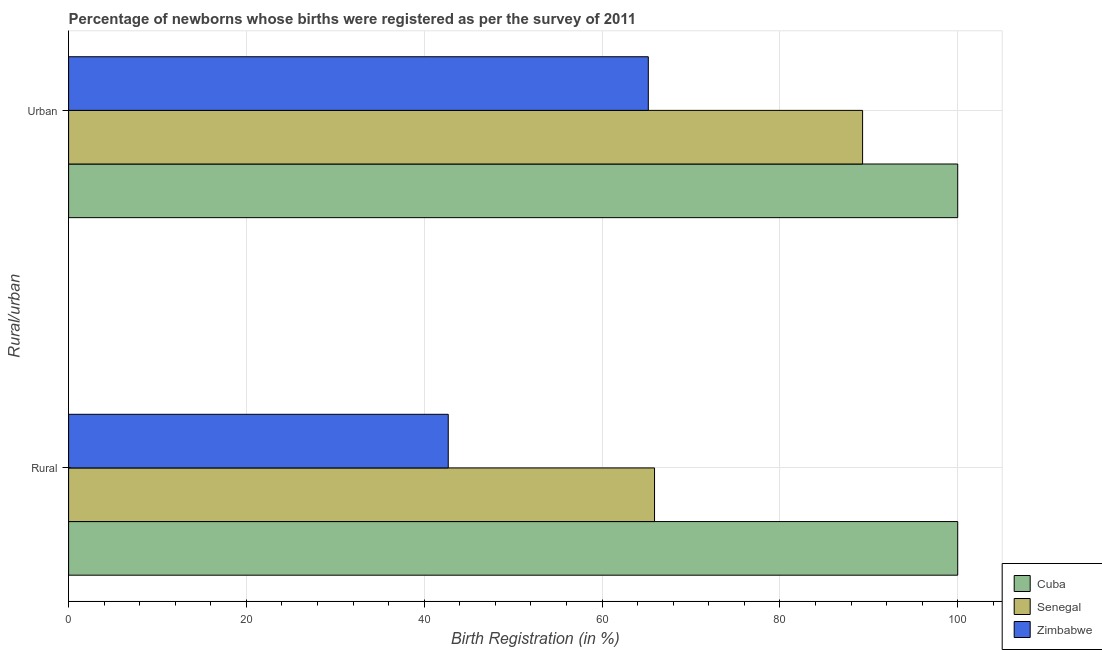How many different coloured bars are there?
Keep it short and to the point. 3. How many groups of bars are there?
Offer a very short reply. 2. Are the number of bars on each tick of the Y-axis equal?
Provide a short and direct response. Yes. What is the label of the 2nd group of bars from the top?
Provide a succinct answer. Rural. Across all countries, what is the minimum urban birth registration?
Keep it short and to the point. 65.2. In which country was the urban birth registration maximum?
Keep it short and to the point. Cuba. In which country was the urban birth registration minimum?
Your response must be concise. Zimbabwe. What is the total rural birth registration in the graph?
Provide a succinct answer. 208.6. What is the difference between the rural birth registration in Senegal and that in Cuba?
Provide a succinct answer. -34.1. What is the difference between the urban birth registration in Zimbabwe and the rural birth registration in Cuba?
Provide a short and direct response. -34.8. What is the average urban birth registration per country?
Give a very brief answer. 84.83. What is the difference between the urban birth registration and rural birth registration in Senegal?
Offer a very short reply. 23.4. In how many countries, is the urban birth registration greater than 12 %?
Give a very brief answer. 3. What is the ratio of the urban birth registration in Zimbabwe to that in Cuba?
Your answer should be very brief. 0.65. In how many countries, is the urban birth registration greater than the average urban birth registration taken over all countries?
Keep it short and to the point. 2. What does the 1st bar from the top in Urban represents?
Keep it short and to the point. Zimbabwe. What does the 1st bar from the bottom in Rural represents?
Provide a succinct answer. Cuba. Are all the bars in the graph horizontal?
Provide a succinct answer. Yes. How many countries are there in the graph?
Your response must be concise. 3. What is the difference between two consecutive major ticks on the X-axis?
Provide a short and direct response. 20. Are the values on the major ticks of X-axis written in scientific E-notation?
Provide a short and direct response. No. Does the graph contain any zero values?
Provide a short and direct response. No. Does the graph contain grids?
Offer a terse response. Yes. Where does the legend appear in the graph?
Offer a terse response. Bottom right. How many legend labels are there?
Offer a very short reply. 3. How are the legend labels stacked?
Your answer should be very brief. Vertical. What is the title of the graph?
Provide a short and direct response. Percentage of newborns whose births were registered as per the survey of 2011. What is the label or title of the X-axis?
Make the answer very short. Birth Registration (in %). What is the label or title of the Y-axis?
Your answer should be very brief. Rural/urban. What is the Birth Registration (in %) in Cuba in Rural?
Your answer should be compact. 100. What is the Birth Registration (in %) in Senegal in Rural?
Your answer should be compact. 65.9. What is the Birth Registration (in %) of Zimbabwe in Rural?
Your answer should be very brief. 42.7. What is the Birth Registration (in %) of Cuba in Urban?
Give a very brief answer. 100. What is the Birth Registration (in %) of Senegal in Urban?
Ensure brevity in your answer.  89.3. What is the Birth Registration (in %) in Zimbabwe in Urban?
Keep it short and to the point. 65.2. Across all Rural/urban, what is the maximum Birth Registration (in %) of Cuba?
Your answer should be very brief. 100. Across all Rural/urban, what is the maximum Birth Registration (in %) in Senegal?
Give a very brief answer. 89.3. Across all Rural/urban, what is the maximum Birth Registration (in %) in Zimbabwe?
Offer a very short reply. 65.2. Across all Rural/urban, what is the minimum Birth Registration (in %) in Senegal?
Your response must be concise. 65.9. Across all Rural/urban, what is the minimum Birth Registration (in %) of Zimbabwe?
Your answer should be very brief. 42.7. What is the total Birth Registration (in %) in Cuba in the graph?
Offer a very short reply. 200. What is the total Birth Registration (in %) in Senegal in the graph?
Offer a very short reply. 155.2. What is the total Birth Registration (in %) in Zimbabwe in the graph?
Keep it short and to the point. 107.9. What is the difference between the Birth Registration (in %) in Senegal in Rural and that in Urban?
Ensure brevity in your answer.  -23.4. What is the difference between the Birth Registration (in %) of Zimbabwe in Rural and that in Urban?
Provide a short and direct response. -22.5. What is the difference between the Birth Registration (in %) of Cuba in Rural and the Birth Registration (in %) of Senegal in Urban?
Your answer should be very brief. 10.7. What is the difference between the Birth Registration (in %) in Cuba in Rural and the Birth Registration (in %) in Zimbabwe in Urban?
Provide a succinct answer. 34.8. What is the average Birth Registration (in %) of Cuba per Rural/urban?
Your answer should be compact. 100. What is the average Birth Registration (in %) in Senegal per Rural/urban?
Provide a succinct answer. 77.6. What is the average Birth Registration (in %) in Zimbabwe per Rural/urban?
Keep it short and to the point. 53.95. What is the difference between the Birth Registration (in %) of Cuba and Birth Registration (in %) of Senegal in Rural?
Offer a very short reply. 34.1. What is the difference between the Birth Registration (in %) in Cuba and Birth Registration (in %) in Zimbabwe in Rural?
Provide a succinct answer. 57.3. What is the difference between the Birth Registration (in %) of Senegal and Birth Registration (in %) of Zimbabwe in Rural?
Your answer should be very brief. 23.2. What is the difference between the Birth Registration (in %) of Cuba and Birth Registration (in %) of Senegal in Urban?
Your response must be concise. 10.7. What is the difference between the Birth Registration (in %) in Cuba and Birth Registration (in %) in Zimbabwe in Urban?
Provide a short and direct response. 34.8. What is the difference between the Birth Registration (in %) in Senegal and Birth Registration (in %) in Zimbabwe in Urban?
Your answer should be very brief. 24.1. What is the ratio of the Birth Registration (in %) of Senegal in Rural to that in Urban?
Provide a succinct answer. 0.74. What is the ratio of the Birth Registration (in %) of Zimbabwe in Rural to that in Urban?
Your response must be concise. 0.65. What is the difference between the highest and the second highest Birth Registration (in %) of Senegal?
Make the answer very short. 23.4. What is the difference between the highest and the second highest Birth Registration (in %) of Zimbabwe?
Your response must be concise. 22.5. What is the difference between the highest and the lowest Birth Registration (in %) in Senegal?
Ensure brevity in your answer.  23.4. What is the difference between the highest and the lowest Birth Registration (in %) of Zimbabwe?
Provide a succinct answer. 22.5. 